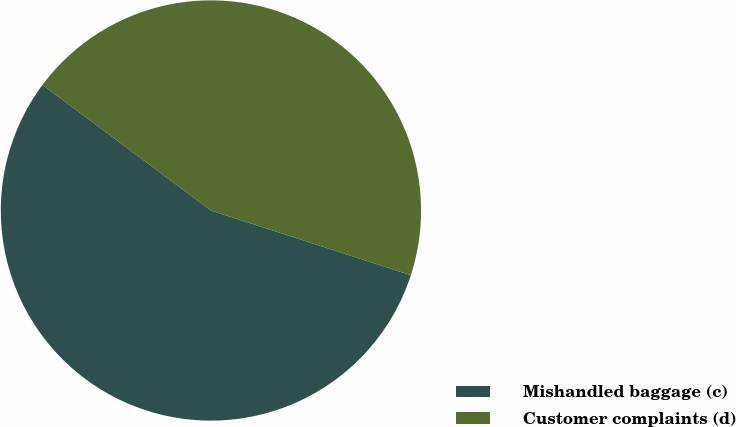Convert chart. <chart><loc_0><loc_0><loc_500><loc_500><pie_chart><fcel>Mishandled baggage (c)<fcel>Customer complaints (d)<nl><fcel>55.22%<fcel>44.78%<nl></chart> 